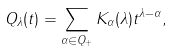<formula> <loc_0><loc_0><loc_500><loc_500>Q _ { \lambda } ( t ) = \sum _ { \alpha \in Q _ { + } } K _ { \alpha } ( \lambda ) t ^ { \lambda - \alpha } ,</formula> 